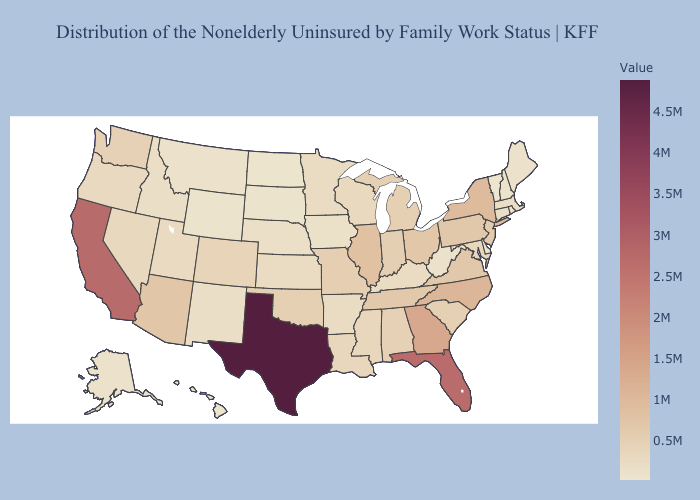Does Wyoming have the lowest value in the USA?
Be succinct. No. Among the states that border Massachusetts , which have the highest value?
Be succinct. New York. Is the legend a continuous bar?
Give a very brief answer. Yes. Which states have the highest value in the USA?
Be succinct. Texas. Among the states that border Florida , does Georgia have the highest value?
Answer briefly. Yes. 